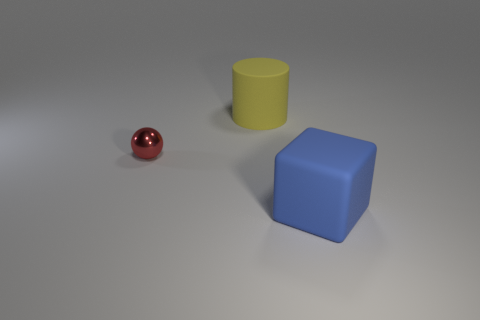Is there any other thing of the same color as the metal ball?
Ensure brevity in your answer.  No. What number of small blue matte objects are there?
Provide a short and direct response. 0. What shape is the object that is both behind the big cube and in front of the big cylinder?
Your answer should be very brief. Sphere. What is the shape of the matte thing behind the matte thing in front of the rubber thing that is to the left of the big blue matte object?
Ensure brevity in your answer.  Cylinder. There is a thing that is both in front of the large yellow cylinder and on the left side of the blue cube; what material is it made of?
Your response must be concise. Metal. What number of purple cubes are the same size as the blue object?
Make the answer very short. 0. How many metallic objects are either yellow cylinders or blue objects?
Offer a terse response. 0. What is the material of the sphere?
Ensure brevity in your answer.  Metal. What number of large rubber blocks are behind the large yellow rubber object?
Provide a short and direct response. 0. Is the material of the large object behind the big blue matte block the same as the tiny sphere?
Your answer should be very brief. No. 